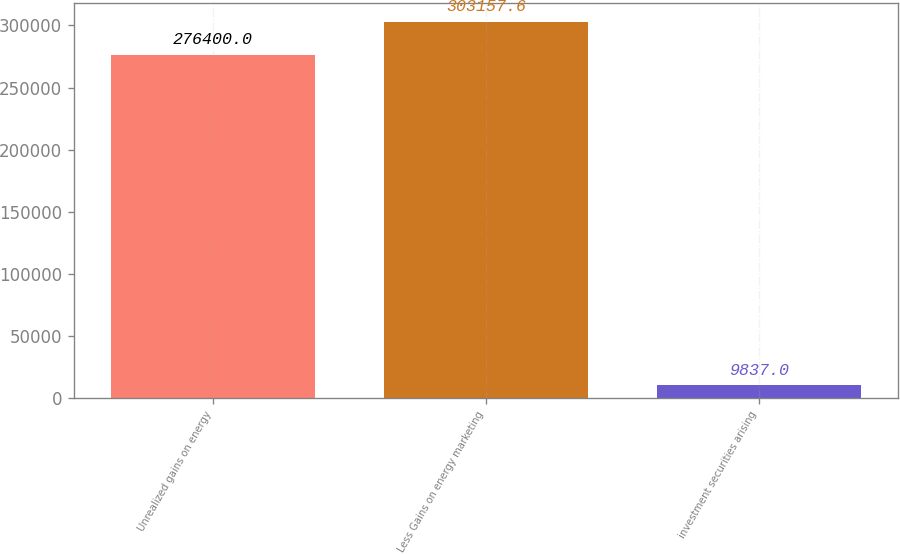Convert chart to OTSL. <chart><loc_0><loc_0><loc_500><loc_500><bar_chart><fcel>Unrealized gains on energy<fcel>Less Gains on energy marketing<fcel>investment securities arising<nl><fcel>276400<fcel>303158<fcel>9837<nl></chart> 